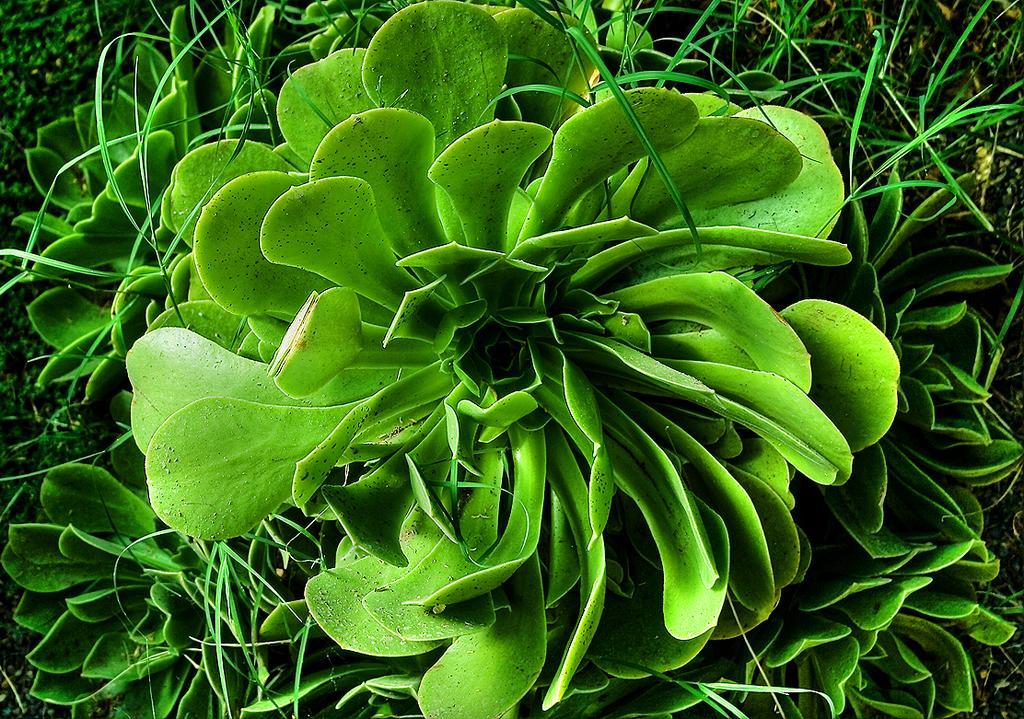How would you summarize this image in a sentence or two? As we can see in the image there are green color plants. 